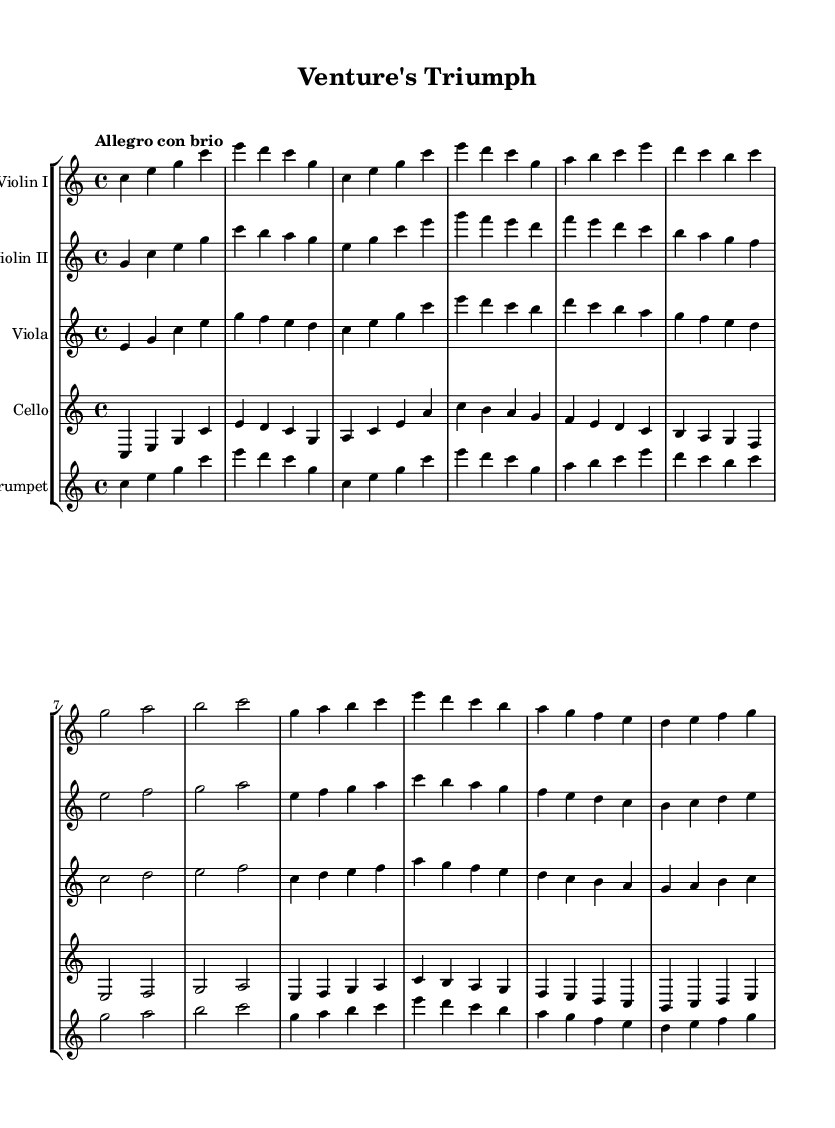What is the title of this piece? The title is indicated in the header section of the sheet music, labeled as "title = 'Venture's Triumph'."
Answer: Venture's Triumph What is the key signature of this music? The key signature is C major, which has no sharps or flats, as identified in the global settings at the beginning of the code.
Answer: C major What is the time signature of this music? The time signature is 4/4, specified in the global settings, indicating four beats per measure.
Answer: 4/4 What is the tempo indication of this piece? The tempo indication, "Allegro con brio," is shown in the global settings, which represents a lively and brisk pace.
Answer: Allegro con brio How many instruments are featured in this score? The score contains five instruments, as indicated by the number of staff lines in the staff group, which are Violin I, Violin II, Viola, Cello, and Trumpet.
Answer: Five What is the main theme labeled in this piece? The main theme is identified as "Main Theme A" and "Main Theme B" in the section comments of the violin parts, distinguishing the two main musical ideas.
Answer: Main Theme A and Main Theme B Identify the mood conveyed by this orchestral score. The tempo marking and lively rhythms throughout suggest a mood of motivation and inspiration, typical for highlighting business success stories.
Answer: Motivational 